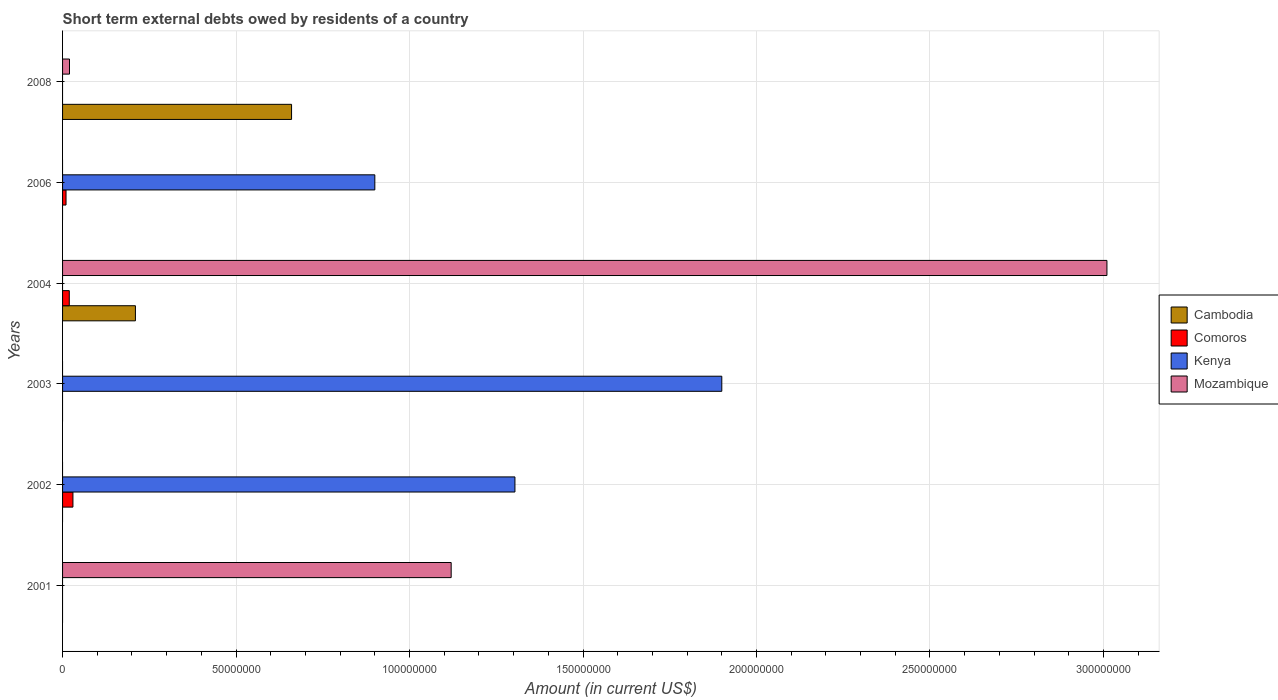How many different coloured bars are there?
Your response must be concise. 4. How many bars are there on the 1st tick from the bottom?
Keep it short and to the point. 1. In how many cases, is the number of bars for a given year not equal to the number of legend labels?
Give a very brief answer. 6. What is the amount of short-term external debts owed by residents in Mozambique in 2008?
Your answer should be compact. 2.00e+06. Across all years, what is the maximum amount of short-term external debts owed by residents in Cambodia?
Provide a succinct answer. 6.60e+07. In which year was the amount of short-term external debts owed by residents in Mozambique maximum?
Provide a short and direct response. 2004. What is the total amount of short-term external debts owed by residents in Comoros in the graph?
Keep it short and to the point. 5.93e+06. What is the difference between the amount of short-term external debts owed by residents in Cambodia in 2004 and that in 2008?
Offer a very short reply. -4.50e+07. What is the difference between the amount of short-term external debts owed by residents in Mozambique in 2004 and the amount of short-term external debts owed by residents in Cambodia in 2003?
Your answer should be very brief. 3.01e+08. What is the average amount of short-term external debts owed by residents in Comoros per year?
Provide a succinct answer. 9.88e+05. In the year 2006, what is the difference between the amount of short-term external debts owed by residents in Comoros and amount of short-term external debts owed by residents in Kenya?
Keep it short and to the point. -8.90e+07. Is the amount of short-term external debts owed by residents in Mozambique in 2001 less than that in 2004?
Provide a short and direct response. Yes. What is the difference between the highest and the second highest amount of short-term external debts owed by residents in Mozambique?
Provide a succinct answer. 1.89e+08. What is the difference between the highest and the lowest amount of short-term external debts owed by residents in Kenya?
Offer a very short reply. 1.90e+08. In how many years, is the amount of short-term external debts owed by residents in Cambodia greater than the average amount of short-term external debts owed by residents in Cambodia taken over all years?
Ensure brevity in your answer.  2. How many years are there in the graph?
Your answer should be compact. 6. What is the difference between two consecutive major ticks on the X-axis?
Your response must be concise. 5.00e+07. Are the values on the major ticks of X-axis written in scientific E-notation?
Your answer should be very brief. No. What is the title of the graph?
Your response must be concise. Short term external debts owed by residents of a country. Does "Egypt, Arab Rep." appear as one of the legend labels in the graph?
Ensure brevity in your answer.  No. What is the Amount (in current US$) of Kenya in 2001?
Your response must be concise. 0. What is the Amount (in current US$) of Mozambique in 2001?
Make the answer very short. 1.12e+08. What is the Amount (in current US$) of Comoros in 2002?
Your answer should be very brief. 2.99e+06. What is the Amount (in current US$) of Kenya in 2002?
Keep it short and to the point. 1.30e+08. What is the Amount (in current US$) in Mozambique in 2002?
Ensure brevity in your answer.  0. What is the Amount (in current US$) in Kenya in 2003?
Offer a very short reply. 1.90e+08. What is the Amount (in current US$) of Cambodia in 2004?
Offer a very short reply. 2.10e+07. What is the Amount (in current US$) in Comoros in 2004?
Give a very brief answer. 1.94e+06. What is the Amount (in current US$) in Mozambique in 2004?
Provide a short and direct response. 3.01e+08. What is the Amount (in current US$) in Cambodia in 2006?
Give a very brief answer. 0. What is the Amount (in current US$) of Comoros in 2006?
Offer a very short reply. 1.00e+06. What is the Amount (in current US$) in Kenya in 2006?
Give a very brief answer. 9.00e+07. What is the Amount (in current US$) of Mozambique in 2006?
Your answer should be compact. 0. What is the Amount (in current US$) in Cambodia in 2008?
Keep it short and to the point. 6.60e+07. What is the Amount (in current US$) of Comoros in 2008?
Your answer should be very brief. 0. What is the Amount (in current US$) of Kenya in 2008?
Ensure brevity in your answer.  0. What is the Amount (in current US$) of Mozambique in 2008?
Offer a very short reply. 2.00e+06. Across all years, what is the maximum Amount (in current US$) of Cambodia?
Your answer should be compact. 6.60e+07. Across all years, what is the maximum Amount (in current US$) of Comoros?
Your answer should be very brief. 2.99e+06. Across all years, what is the maximum Amount (in current US$) in Kenya?
Offer a terse response. 1.90e+08. Across all years, what is the maximum Amount (in current US$) of Mozambique?
Your response must be concise. 3.01e+08. Across all years, what is the minimum Amount (in current US$) in Mozambique?
Offer a terse response. 0. What is the total Amount (in current US$) of Cambodia in the graph?
Provide a succinct answer. 8.70e+07. What is the total Amount (in current US$) of Comoros in the graph?
Your response must be concise. 5.93e+06. What is the total Amount (in current US$) of Kenya in the graph?
Offer a terse response. 4.10e+08. What is the total Amount (in current US$) in Mozambique in the graph?
Your answer should be very brief. 4.15e+08. What is the difference between the Amount (in current US$) in Mozambique in 2001 and that in 2004?
Give a very brief answer. -1.89e+08. What is the difference between the Amount (in current US$) in Mozambique in 2001 and that in 2008?
Give a very brief answer. 1.10e+08. What is the difference between the Amount (in current US$) of Kenya in 2002 and that in 2003?
Provide a succinct answer. -5.96e+07. What is the difference between the Amount (in current US$) in Comoros in 2002 and that in 2004?
Offer a very short reply. 1.05e+06. What is the difference between the Amount (in current US$) of Comoros in 2002 and that in 2006?
Provide a succinct answer. 1.99e+06. What is the difference between the Amount (in current US$) of Kenya in 2002 and that in 2006?
Offer a very short reply. 4.04e+07. What is the difference between the Amount (in current US$) of Comoros in 2004 and that in 2006?
Your response must be concise. 9.36e+05. What is the difference between the Amount (in current US$) of Cambodia in 2004 and that in 2008?
Keep it short and to the point. -4.50e+07. What is the difference between the Amount (in current US$) of Mozambique in 2004 and that in 2008?
Your answer should be compact. 2.99e+08. What is the difference between the Amount (in current US$) of Comoros in 2002 and the Amount (in current US$) of Kenya in 2003?
Your response must be concise. -1.87e+08. What is the difference between the Amount (in current US$) of Comoros in 2002 and the Amount (in current US$) of Mozambique in 2004?
Your response must be concise. -2.98e+08. What is the difference between the Amount (in current US$) of Kenya in 2002 and the Amount (in current US$) of Mozambique in 2004?
Offer a very short reply. -1.71e+08. What is the difference between the Amount (in current US$) of Comoros in 2002 and the Amount (in current US$) of Kenya in 2006?
Provide a succinct answer. -8.70e+07. What is the difference between the Amount (in current US$) of Comoros in 2002 and the Amount (in current US$) of Mozambique in 2008?
Make the answer very short. 9.90e+05. What is the difference between the Amount (in current US$) of Kenya in 2002 and the Amount (in current US$) of Mozambique in 2008?
Your response must be concise. 1.28e+08. What is the difference between the Amount (in current US$) of Kenya in 2003 and the Amount (in current US$) of Mozambique in 2004?
Keep it short and to the point. -1.11e+08. What is the difference between the Amount (in current US$) of Kenya in 2003 and the Amount (in current US$) of Mozambique in 2008?
Make the answer very short. 1.88e+08. What is the difference between the Amount (in current US$) of Cambodia in 2004 and the Amount (in current US$) of Kenya in 2006?
Your answer should be compact. -6.90e+07. What is the difference between the Amount (in current US$) of Comoros in 2004 and the Amount (in current US$) of Kenya in 2006?
Keep it short and to the point. -8.81e+07. What is the difference between the Amount (in current US$) in Cambodia in 2004 and the Amount (in current US$) in Mozambique in 2008?
Provide a succinct answer. 1.90e+07. What is the difference between the Amount (in current US$) of Comoros in 2004 and the Amount (in current US$) of Mozambique in 2008?
Make the answer very short. -6.40e+04. What is the difference between the Amount (in current US$) of Comoros in 2006 and the Amount (in current US$) of Mozambique in 2008?
Provide a short and direct response. -1.00e+06. What is the difference between the Amount (in current US$) in Kenya in 2006 and the Amount (in current US$) in Mozambique in 2008?
Ensure brevity in your answer.  8.80e+07. What is the average Amount (in current US$) in Cambodia per year?
Give a very brief answer. 1.45e+07. What is the average Amount (in current US$) of Comoros per year?
Your response must be concise. 9.88e+05. What is the average Amount (in current US$) in Kenya per year?
Make the answer very short. 6.84e+07. What is the average Amount (in current US$) in Mozambique per year?
Give a very brief answer. 6.92e+07. In the year 2002, what is the difference between the Amount (in current US$) in Comoros and Amount (in current US$) in Kenya?
Provide a short and direct response. -1.27e+08. In the year 2004, what is the difference between the Amount (in current US$) of Cambodia and Amount (in current US$) of Comoros?
Offer a very short reply. 1.91e+07. In the year 2004, what is the difference between the Amount (in current US$) of Cambodia and Amount (in current US$) of Mozambique?
Your answer should be compact. -2.80e+08. In the year 2004, what is the difference between the Amount (in current US$) in Comoros and Amount (in current US$) in Mozambique?
Offer a very short reply. -2.99e+08. In the year 2006, what is the difference between the Amount (in current US$) in Comoros and Amount (in current US$) in Kenya?
Keep it short and to the point. -8.90e+07. In the year 2008, what is the difference between the Amount (in current US$) in Cambodia and Amount (in current US$) in Mozambique?
Your answer should be very brief. 6.40e+07. What is the ratio of the Amount (in current US$) of Mozambique in 2001 to that in 2004?
Make the answer very short. 0.37. What is the ratio of the Amount (in current US$) in Kenya in 2002 to that in 2003?
Your response must be concise. 0.69. What is the ratio of the Amount (in current US$) in Comoros in 2002 to that in 2004?
Your answer should be compact. 1.54. What is the ratio of the Amount (in current US$) of Comoros in 2002 to that in 2006?
Provide a short and direct response. 2.99. What is the ratio of the Amount (in current US$) in Kenya in 2002 to that in 2006?
Give a very brief answer. 1.45. What is the ratio of the Amount (in current US$) of Kenya in 2003 to that in 2006?
Provide a succinct answer. 2.11. What is the ratio of the Amount (in current US$) in Comoros in 2004 to that in 2006?
Your response must be concise. 1.94. What is the ratio of the Amount (in current US$) of Cambodia in 2004 to that in 2008?
Your response must be concise. 0.32. What is the ratio of the Amount (in current US$) in Mozambique in 2004 to that in 2008?
Provide a succinct answer. 150.5. What is the difference between the highest and the second highest Amount (in current US$) in Comoros?
Make the answer very short. 1.05e+06. What is the difference between the highest and the second highest Amount (in current US$) of Kenya?
Make the answer very short. 5.96e+07. What is the difference between the highest and the second highest Amount (in current US$) in Mozambique?
Give a very brief answer. 1.89e+08. What is the difference between the highest and the lowest Amount (in current US$) in Cambodia?
Your answer should be compact. 6.60e+07. What is the difference between the highest and the lowest Amount (in current US$) in Comoros?
Provide a short and direct response. 2.99e+06. What is the difference between the highest and the lowest Amount (in current US$) of Kenya?
Ensure brevity in your answer.  1.90e+08. What is the difference between the highest and the lowest Amount (in current US$) of Mozambique?
Give a very brief answer. 3.01e+08. 